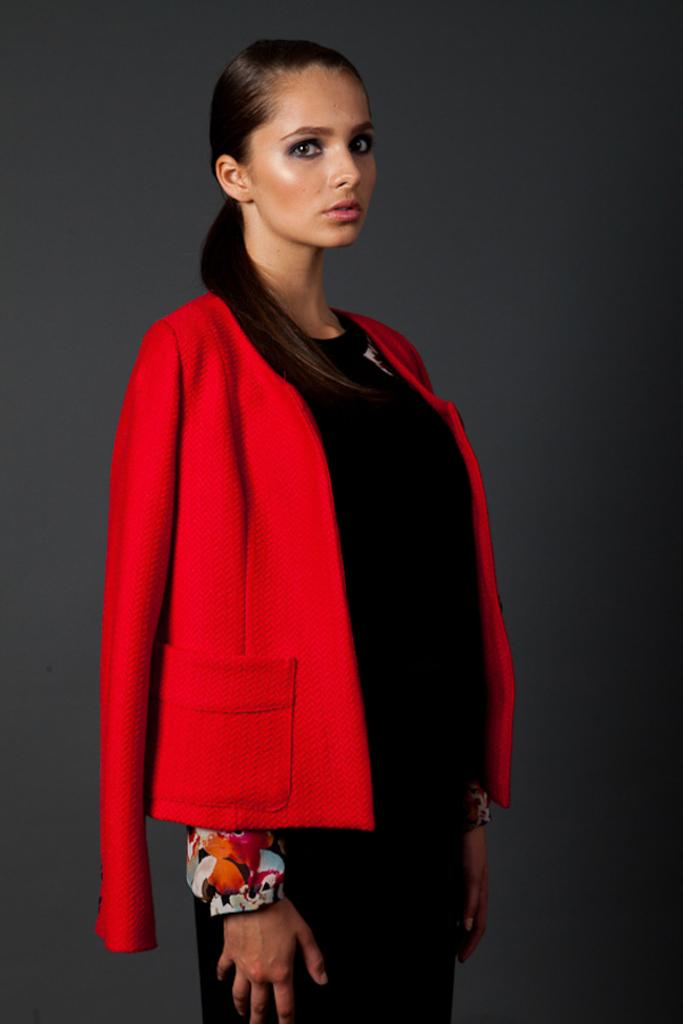What is the main subject of the image? The main subject of the image is a woman. What is the woman wearing in the image? The woman is wearing a red coat in the image. What is the woman's posture in the image? The woman is standing in the image. What type of liquid is the woman begging for in the image? There is no indication in the image that the woman is begging for anything, let alone a liquid. 